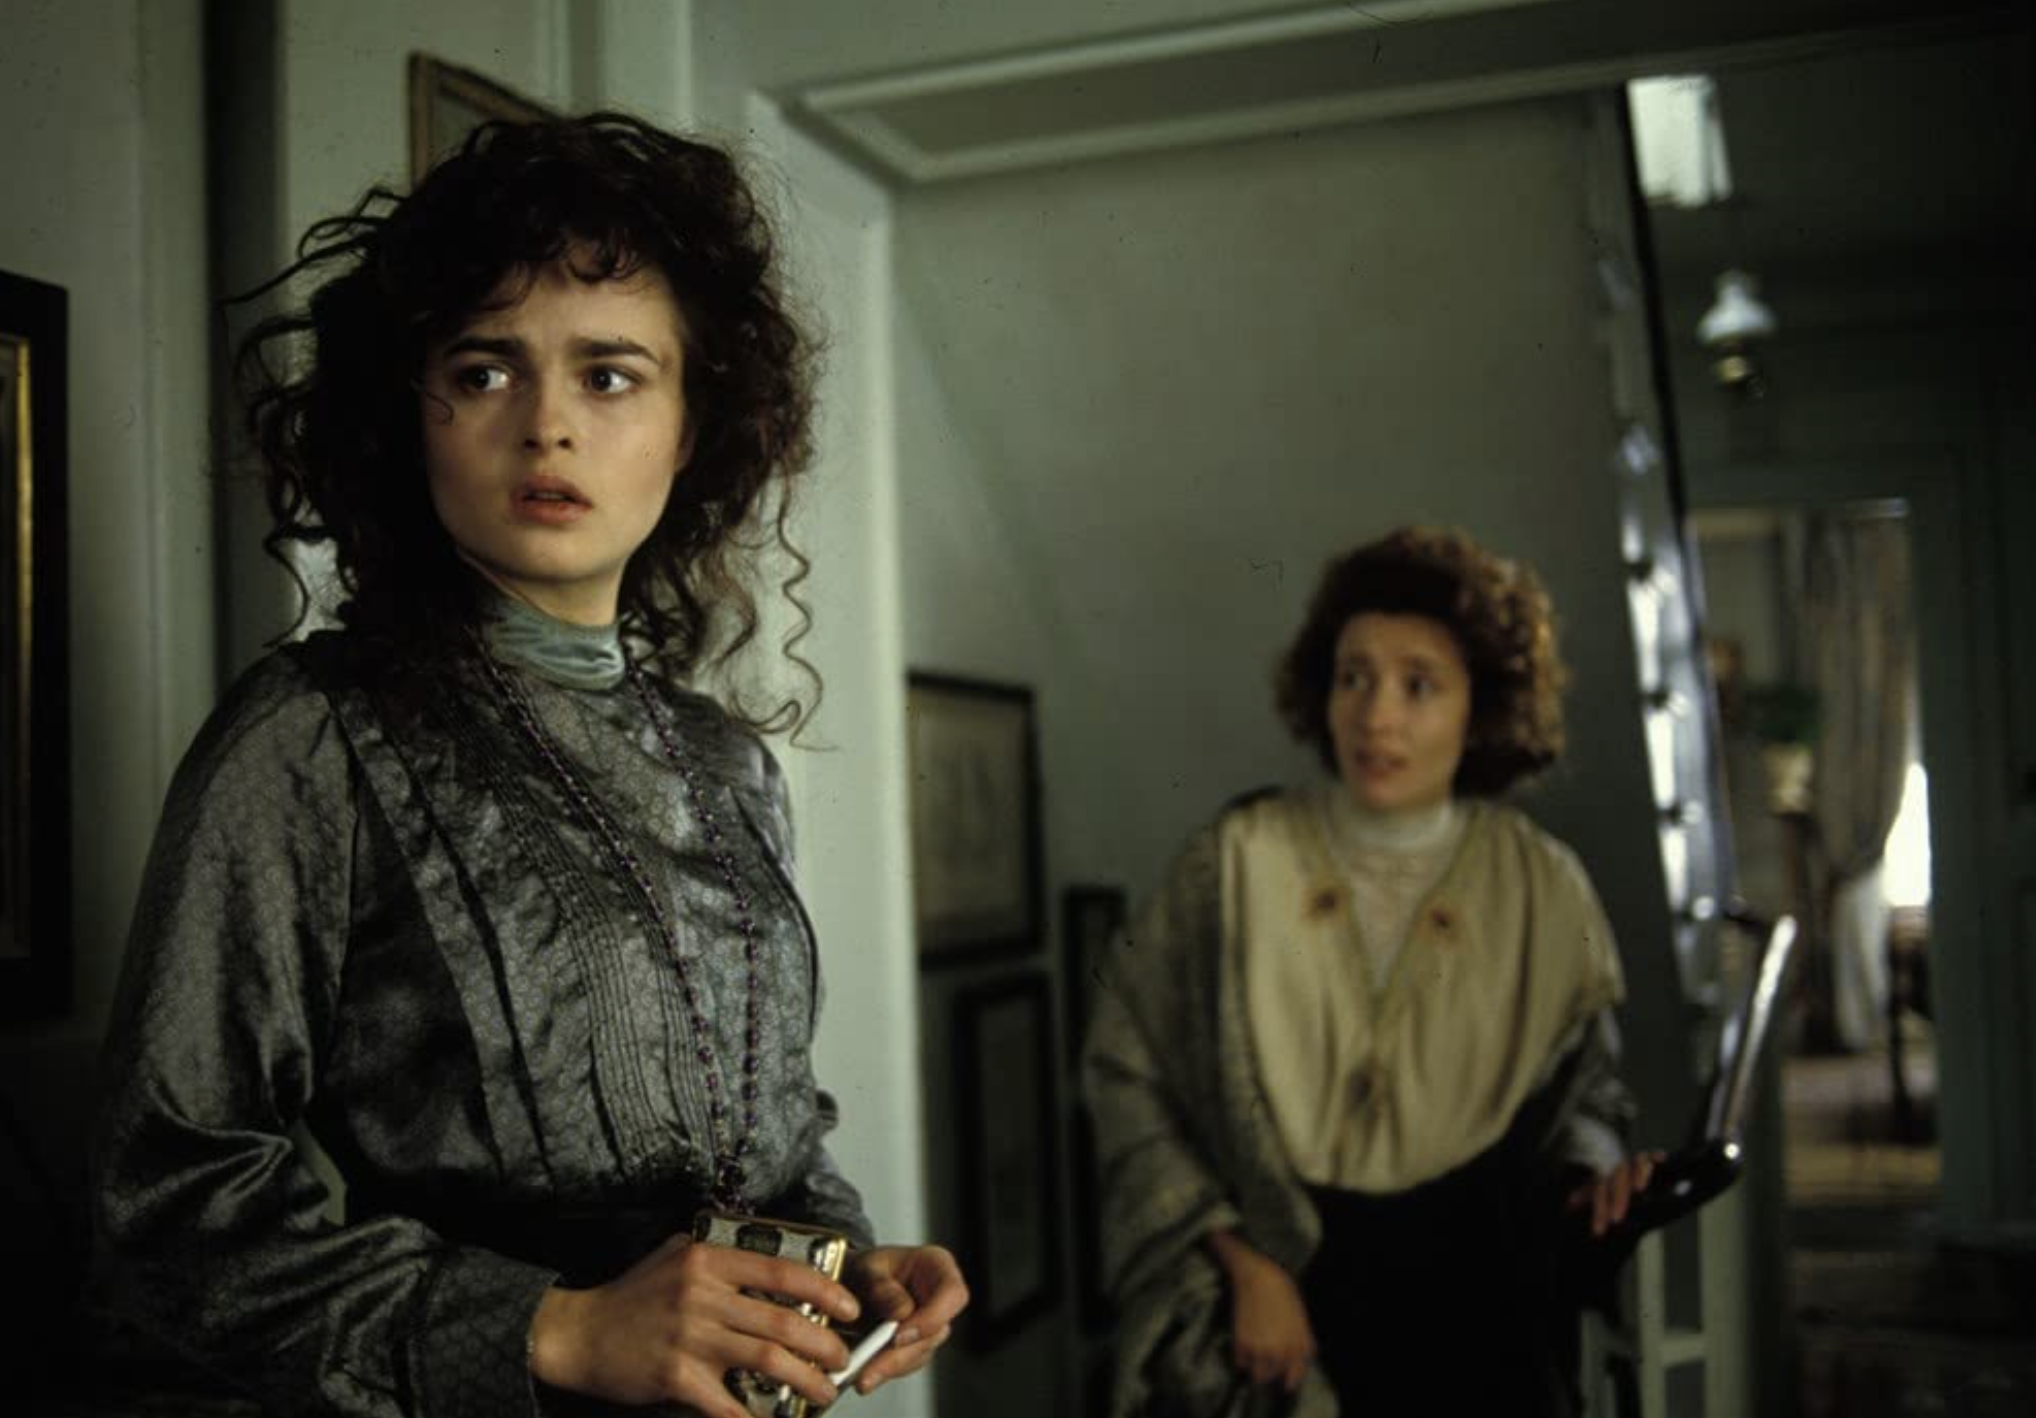What narrative could this image represent? The scene depicted could represent a pivotal moment in a narrative involving a personal dilemma or a social issue of the time. The foreground character’s body language and facial expression might indicate a turning point or realization, while the person in the background could signify a companion or confidant. This setting might easily fit into a larger story exploring themes of self-discovery, societal expectations, or interpersonal relationships. 